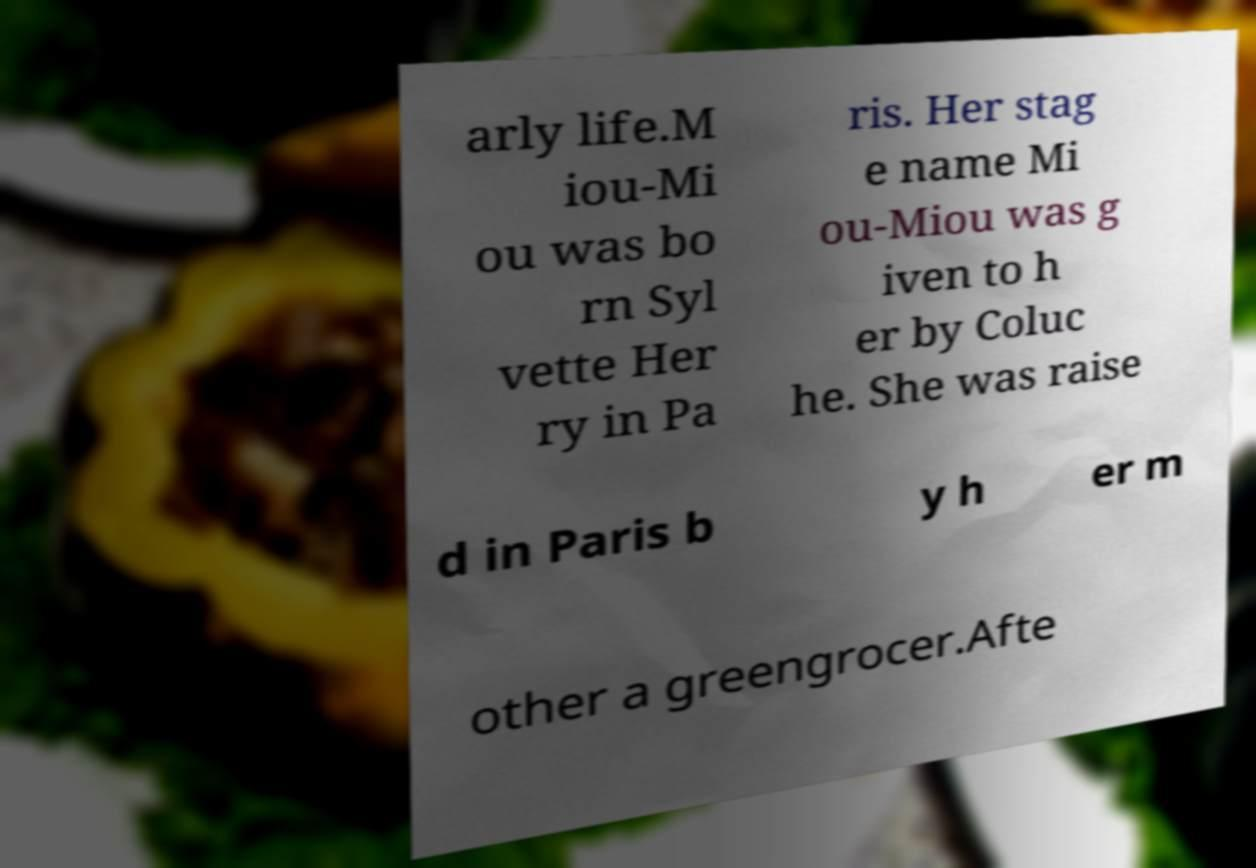For documentation purposes, I need the text within this image transcribed. Could you provide that? arly life.M iou-Mi ou was bo rn Syl vette Her ry in Pa ris. Her stag e name Mi ou-Miou was g iven to h er by Coluc he. She was raise d in Paris b y h er m other a greengrocer.Afte 